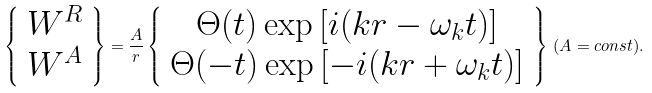<formula> <loc_0><loc_0><loc_500><loc_500>\left \{ \begin{array} { c } W ^ { R } \\ W ^ { A } \end{array} \right \} = \frac { A } { r } \left \{ \begin{array} { c } \Theta ( t ) \exp \left [ i ( k r - \omega _ { k } t ) \right ] \\ \Theta ( - t ) \exp \left [ - i ( k r + \omega _ { k } t ) \right ] \end{array} \right \} \, ( A = c o n s t ) .</formula> 